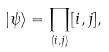<formula> <loc_0><loc_0><loc_500><loc_500>| \psi \rangle = \prod _ { ( i , j ) } [ i , j ] ,</formula> 